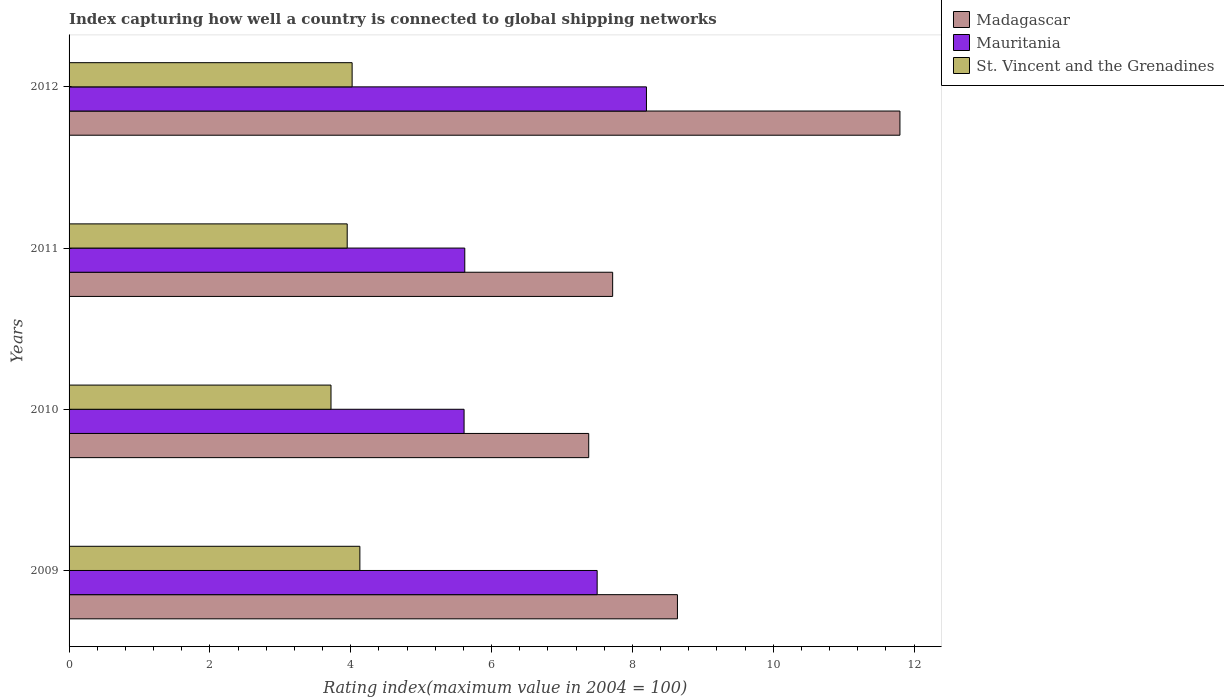How many different coloured bars are there?
Your response must be concise. 3. Are the number of bars per tick equal to the number of legend labels?
Make the answer very short. Yes. What is the label of the 2nd group of bars from the top?
Ensure brevity in your answer.  2011. In how many cases, is the number of bars for a given year not equal to the number of legend labels?
Keep it short and to the point. 0. What is the rating index in Mauritania in 2011?
Give a very brief answer. 5.62. Across all years, what is the maximum rating index in Madagascar?
Your response must be concise. 11.8. Across all years, what is the minimum rating index in St. Vincent and the Grenadines?
Your answer should be compact. 3.72. In which year was the rating index in Madagascar maximum?
Your response must be concise. 2012. What is the total rating index in Mauritania in the graph?
Give a very brief answer. 26.93. What is the difference between the rating index in Mauritania in 2009 and that in 2011?
Provide a short and direct response. 1.88. What is the difference between the rating index in St. Vincent and the Grenadines in 2009 and the rating index in Mauritania in 2011?
Give a very brief answer. -1.49. What is the average rating index in St. Vincent and the Grenadines per year?
Your answer should be very brief. 3.96. In the year 2011, what is the difference between the rating index in Madagascar and rating index in St. Vincent and the Grenadines?
Your response must be concise. 3.77. In how many years, is the rating index in Madagascar greater than 4 ?
Offer a very short reply. 4. What is the ratio of the rating index in Mauritania in 2011 to that in 2012?
Your response must be concise. 0.69. What is the difference between the highest and the second highest rating index in Mauritania?
Your answer should be compact. 0.7. What is the difference between the highest and the lowest rating index in Madagascar?
Give a very brief answer. 4.42. In how many years, is the rating index in St. Vincent and the Grenadines greater than the average rating index in St. Vincent and the Grenadines taken over all years?
Make the answer very short. 2. What does the 1st bar from the top in 2010 represents?
Ensure brevity in your answer.  St. Vincent and the Grenadines. What does the 1st bar from the bottom in 2011 represents?
Your answer should be very brief. Madagascar. Is it the case that in every year, the sum of the rating index in Madagascar and rating index in Mauritania is greater than the rating index in St. Vincent and the Grenadines?
Your response must be concise. Yes. How many bars are there?
Keep it short and to the point. 12. Are all the bars in the graph horizontal?
Your answer should be very brief. Yes. What is the difference between two consecutive major ticks on the X-axis?
Make the answer very short. 2. Does the graph contain any zero values?
Your response must be concise. No. Does the graph contain grids?
Your answer should be very brief. No. Where does the legend appear in the graph?
Offer a terse response. Top right. How many legend labels are there?
Offer a very short reply. 3. What is the title of the graph?
Ensure brevity in your answer.  Index capturing how well a country is connected to global shipping networks. Does "Vietnam" appear as one of the legend labels in the graph?
Keep it short and to the point. No. What is the label or title of the X-axis?
Give a very brief answer. Rating index(maximum value in 2004 = 100). What is the label or title of the Y-axis?
Your answer should be very brief. Years. What is the Rating index(maximum value in 2004 = 100) of Madagascar in 2009?
Your answer should be very brief. 8.64. What is the Rating index(maximum value in 2004 = 100) in Mauritania in 2009?
Provide a short and direct response. 7.5. What is the Rating index(maximum value in 2004 = 100) in St. Vincent and the Grenadines in 2009?
Give a very brief answer. 4.13. What is the Rating index(maximum value in 2004 = 100) of Madagascar in 2010?
Provide a short and direct response. 7.38. What is the Rating index(maximum value in 2004 = 100) of Mauritania in 2010?
Provide a short and direct response. 5.61. What is the Rating index(maximum value in 2004 = 100) of St. Vincent and the Grenadines in 2010?
Provide a short and direct response. 3.72. What is the Rating index(maximum value in 2004 = 100) in Madagascar in 2011?
Give a very brief answer. 7.72. What is the Rating index(maximum value in 2004 = 100) of Mauritania in 2011?
Your answer should be compact. 5.62. What is the Rating index(maximum value in 2004 = 100) in St. Vincent and the Grenadines in 2011?
Your response must be concise. 3.95. What is the Rating index(maximum value in 2004 = 100) of Madagascar in 2012?
Your response must be concise. 11.8. What is the Rating index(maximum value in 2004 = 100) in St. Vincent and the Grenadines in 2012?
Ensure brevity in your answer.  4.02. Across all years, what is the maximum Rating index(maximum value in 2004 = 100) of St. Vincent and the Grenadines?
Your response must be concise. 4.13. Across all years, what is the minimum Rating index(maximum value in 2004 = 100) in Madagascar?
Keep it short and to the point. 7.38. Across all years, what is the minimum Rating index(maximum value in 2004 = 100) in Mauritania?
Offer a terse response. 5.61. Across all years, what is the minimum Rating index(maximum value in 2004 = 100) in St. Vincent and the Grenadines?
Your answer should be very brief. 3.72. What is the total Rating index(maximum value in 2004 = 100) in Madagascar in the graph?
Offer a very short reply. 35.54. What is the total Rating index(maximum value in 2004 = 100) in Mauritania in the graph?
Your answer should be compact. 26.93. What is the total Rating index(maximum value in 2004 = 100) in St. Vincent and the Grenadines in the graph?
Your answer should be very brief. 15.82. What is the difference between the Rating index(maximum value in 2004 = 100) of Madagascar in 2009 and that in 2010?
Provide a succinct answer. 1.26. What is the difference between the Rating index(maximum value in 2004 = 100) in Mauritania in 2009 and that in 2010?
Keep it short and to the point. 1.89. What is the difference between the Rating index(maximum value in 2004 = 100) of St. Vincent and the Grenadines in 2009 and that in 2010?
Ensure brevity in your answer.  0.41. What is the difference between the Rating index(maximum value in 2004 = 100) of Madagascar in 2009 and that in 2011?
Ensure brevity in your answer.  0.92. What is the difference between the Rating index(maximum value in 2004 = 100) of Mauritania in 2009 and that in 2011?
Make the answer very short. 1.88. What is the difference between the Rating index(maximum value in 2004 = 100) of St. Vincent and the Grenadines in 2009 and that in 2011?
Give a very brief answer. 0.18. What is the difference between the Rating index(maximum value in 2004 = 100) of Madagascar in 2009 and that in 2012?
Ensure brevity in your answer.  -3.16. What is the difference between the Rating index(maximum value in 2004 = 100) of Mauritania in 2009 and that in 2012?
Make the answer very short. -0.7. What is the difference between the Rating index(maximum value in 2004 = 100) of St. Vincent and the Grenadines in 2009 and that in 2012?
Offer a very short reply. 0.11. What is the difference between the Rating index(maximum value in 2004 = 100) of Madagascar in 2010 and that in 2011?
Give a very brief answer. -0.34. What is the difference between the Rating index(maximum value in 2004 = 100) of Mauritania in 2010 and that in 2011?
Offer a terse response. -0.01. What is the difference between the Rating index(maximum value in 2004 = 100) of St. Vincent and the Grenadines in 2010 and that in 2011?
Ensure brevity in your answer.  -0.23. What is the difference between the Rating index(maximum value in 2004 = 100) of Madagascar in 2010 and that in 2012?
Provide a short and direct response. -4.42. What is the difference between the Rating index(maximum value in 2004 = 100) of Mauritania in 2010 and that in 2012?
Your answer should be compact. -2.59. What is the difference between the Rating index(maximum value in 2004 = 100) in St. Vincent and the Grenadines in 2010 and that in 2012?
Provide a short and direct response. -0.3. What is the difference between the Rating index(maximum value in 2004 = 100) in Madagascar in 2011 and that in 2012?
Offer a very short reply. -4.08. What is the difference between the Rating index(maximum value in 2004 = 100) in Mauritania in 2011 and that in 2012?
Ensure brevity in your answer.  -2.58. What is the difference between the Rating index(maximum value in 2004 = 100) of St. Vincent and the Grenadines in 2011 and that in 2012?
Keep it short and to the point. -0.07. What is the difference between the Rating index(maximum value in 2004 = 100) in Madagascar in 2009 and the Rating index(maximum value in 2004 = 100) in Mauritania in 2010?
Provide a succinct answer. 3.03. What is the difference between the Rating index(maximum value in 2004 = 100) in Madagascar in 2009 and the Rating index(maximum value in 2004 = 100) in St. Vincent and the Grenadines in 2010?
Your response must be concise. 4.92. What is the difference between the Rating index(maximum value in 2004 = 100) of Mauritania in 2009 and the Rating index(maximum value in 2004 = 100) of St. Vincent and the Grenadines in 2010?
Keep it short and to the point. 3.78. What is the difference between the Rating index(maximum value in 2004 = 100) of Madagascar in 2009 and the Rating index(maximum value in 2004 = 100) of Mauritania in 2011?
Make the answer very short. 3.02. What is the difference between the Rating index(maximum value in 2004 = 100) in Madagascar in 2009 and the Rating index(maximum value in 2004 = 100) in St. Vincent and the Grenadines in 2011?
Offer a very short reply. 4.69. What is the difference between the Rating index(maximum value in 2004 = 100) of Mauritania in 2009 and the Rating index(maximum value in 2004 = 100) of St. Vincent and the Grenadines in 2011?
Provide a succinct answer. 3.55. What is the difference between the Rating index(maximum value in 2004 = 100) of Madagascar in 2009 and the Rating index(maximum value in 2004 = 100) of Mauritania in 2012?
Give a very brief answer. 0.44. What is the difference between the Rating index(maximum value in 2004 = 100) in Madagascar in 2009 and the Rating index(maximum value in 2004 = 100) in St. Vincent and the Grenadines in 2012?
Your response must be concise. 4.62. What is the difference between the Rating index(maximum value in 2004 = 100) in Mauritania in 2009 and the Rating index(maximum value in 2004 = 100) in St. Vincent and the Grenadines in 2012?
Your response must be concise. 3.48. What is the difference between the Rating index(maximum value in 2004 = 100) in Madagascar in 2010 and the Rating index(maximum value in 2004 = 100) in Mauritania in 2011?
Give a very brief answer. 1.76. What is the difference between the Rating index(maximum value in 2004 = 100) of Madagascar in 2010 and the Rating index(maximum value in 2004 = 100) of St. Vincent and the Grenadines in 2011?
Offer a terse response. 3.43. What is the difference between the Rating index(maximum value in 2004 = 100) of Mauritania in 2010 and the Rating index(maximum value in 2004 = 100) of St. Vincent and the Grenadines in 2011?
Make the answer very short. 1.66. What is the difference between the Rating index(maximum value in 2004 = 100) of Madagascar in 2010 and the Rating index(maximum value in 2004 = 100) of Mauritania in 2012?
Provide a succinct answer. -0.82. What is the difference between the Rating index(maximum value in 2004 = 100) of Madagascar in 2010 and the Rating index(maximum value in 2004 = 100) of St. Vincent and the Grenadines in 2012?
Provide a succinct answer. 3.36. What is the difference between the Rating index(maximum value in 2004 = 100) of Mauritania in 2010 and the Rating index(maximum value in 2004 = 100) of St. Vincent and the Grenadines in 2012?
Keep it short and to the point. 1.59. What is the difference between the Rating index(maximum value in 2004 = 100) of Madagascar in 2011 and the Rating index(maximum value in 2004 = 100) of Mauritania in 2012?
Ensure brevity in your answer.  -0.48. What is the difference between the Rating index(maximum value in 2004 = 100) in Madagascar in 2011 and the Rating index(maximum value in 2004 = 100) in St. Vincent and the Grenadines in 2012?
Offer a very short reply. 3.7. What is the average Rating index(maximum value in 2004 = 100) of Madagascar per year?
Give a very brief answer. 8.88. What is the average Rating index(maximum value in 2004 = 100) of Mauritania per year?
Provide a short and direct response. 6.73. What is the average Rating index(maximum value in 2004 = 100) of St. Vincent and the Grenadines per year?
Provide a succinct answer. 3.96. In the year 2009, what is the difference between the Rating index(maximum value in 2004 = 100) of Madagascar and Rating index(maximum value in 2004 = 100) of Mauritania?
Keep it short and to the point. 1.14. In the year 2009, what is the difference between the Rating index(maximum value in 2004 = 100) of Madagascar and Rating index(maximum value in 2004 = 100) of St. Vincent and the Grenadines?
Ensure brevity in your answer.  4.51. In the year 2009, what is the difference between the Rating index(maximum value in 2004 = 100) in Mauritania and Rating index(maximum value in 2004 = 100) in St. Vincent and the Grenadines?
Your answer should be very brief. 3.37. In the year 2010, what is the difference between the Rating index(maximum value in 2004 = 100) of Madagascar and Rating index(maximum value in 2004 = 100) of Mauritania?
Ensure brevity in your answer.  1.77. In the year 2010, what is the difference between the Rating index(maximum value in 2004 = 100) in Madagascar and Rating index(maximum value in 2004 = 100) in St. Vincent and the Grenadines?
Your answer should be very brief. 3.66. In the year 2010, what is the difference between the Rating index(maximum value in 2004 = 100) in Mauritania and Rating index(maximum value in 2004 = 100) in St. Vincent and the Grenadines?
Your answer should be compact. 1.89. In the year 2011, what is the difference between the Rating index(maximum value in 2004 = 100) of Madagascar and Rating index(maximum value in 2004 = 100) of Mauritania?
Keep it short and to the point. 2.1. In the year 2011, what is the difference between the Rating index(maximum value in 2004 = 100) in Madagascar and Rating index(maximum value in 2004 = 100) in St. Vincent and the Grenadines?
Provide a short and direct response. 3.77. In the year 2011, what is the difference between the Rating index(maximum value in 2004 = 100) of Mauritania and Rating index(maximum value in 2004 = 100) of St. Vincent and the Grenadines?
Keep it short and to the point. 1.67. In the year 2012, what is the difference between the Rating index(maximum value in 2004 = 100) of Madagascar and Rating index(maximum value in 2004 = 100) of St. Vincent and the Grenadines?
Your response must be concise. 7.78. In the year 2012, what is the difference between the Rating index(maximum value in 2004 = 100) in Mauritania and Rating index(maximum value in 2004 = 100) in St. Vincent and the Grenadines?
Make the answer very short. 4.18. What is the ratio of the Rating index(maximum value in 2004 = 100) in Madagascar in 2009 to that in 2010?
Make the answer very short. 1.17. What is the ratio of the Rating index(maximum value in 2004 = 100) in Mauritania in 2009 to that in 2010?
Your answer should be very brief. 1.34. What is the ratio of the Rating index(maximum value in 2004 = 100) in St. Vincent and the Grenadines in 2009 to that in 2010?
Offer a terse response. 1.11. What is the ratio of the Rating index(maximum value in 2004 = 100) in Madagascar in 2009 to that in 2011?
Make the answer very short. 1.12. What is the ratio of the Rating index(maximum value in 2004 = 100) of Mauritania in 2009 to that in 2011?
Your response must be concise. 1.33. What is the ratio of the Rating index(maximum value in 2004 = 100) in St. Vincent and the Grenadines in 2009 to that in 2011?
Keep it short and to the point. 1.05. What is the ratio of the Rating index(maximum value in 2004 = 100) in Madagascar in 2009 to that in 2012?
Provide a succinct answer. 0.73. What is the ratio of the Rating index(maximum value in 2004 = 100) in Mauritania in 2009 to that in 2012?
Provide a succinct answer. 0.91. What is the ratio of the Rating index(maximum value in 2004 = 100) of St. Vincent and the Grenadines in 2009 to that in 2012?
Your answer should be very brief. 1.03. What is the ratio of the Rating index(maximum value in 2004 = 100) of Madagascar in 2010 to that in 2011?
Offer a terse response. 0.96. What is the ratio of the Rating index(maximum value in 2004 = 100) of Mauritania in 2010 to that in 2011?
Your answer should be very brief. 1. What is the ratio of the Rating index(maximum value in 2004 = 100) in St. Vincent and the Grenadines in 2010 to that in 2011?
Provide a succinct answer. 0.94. What is the ratio of the Rating index(maximum value in 2004 = 100) in Madagascar in 2010 to that in 2012?
Offer a very short reply. 0.63. What is the ratio of the Rating index(maximum value in 2004 = 100) in Mauritania in 2010 to that in 2012?
Provide a short and direct response. 0.68. What is the ratio of the Rating index(maximum value in 2004 = 100) of St. Vincent and the Grenadines in 2010 to that in 2012?
Offer a terse response. 0.93. What is the ratio of the Rating index(maximum value in 2004 = 100) in Madagascar in 2011 to that in 2012?
Your answer should be very brief. 0.65. What is the ratio of the Rating index(maximum value in 2004 = 100) in Mauritania in 2011 to that in 2012?
Make the answer very short. 0.69. What is the ratio of the Rating index(maximum value in 2004 = 100) of St. Vincent and the Grenadines in 2011 to that in 2012?
Offer a terse response. 0.98. What is the difference between the highest and the second highest Rating index(maximum value in 2004 = 100) in Madagascar?
Your answer should be compact. 3.16. What is the difference between the highest and the second highest Rating index(maximum value in 2004 = 100) in Mauritania?
Offer a very short reply. 0.7. What is the difference between the highest and the second highest Rating index(maximum value in 2004 = 100) in St. Vincent and the Grenadines?
Your answer should be compact. 0.11. What is the difference between the highest and the lowest Rating index(maximum value in 2004 = 100) of Madagascar?
Provide a succinct answer. 4.42. What is the difference between the highest and the lowest Rating index(maximum value in 2004 = 100) of Mauritania?
Make the answer very short. 2.59. What is the difference between the highest and the lowest Rating index(maximum value in 2004 = 100) of St. Vincent and the Grenadines?
Give a very brief answer. 0.41. 